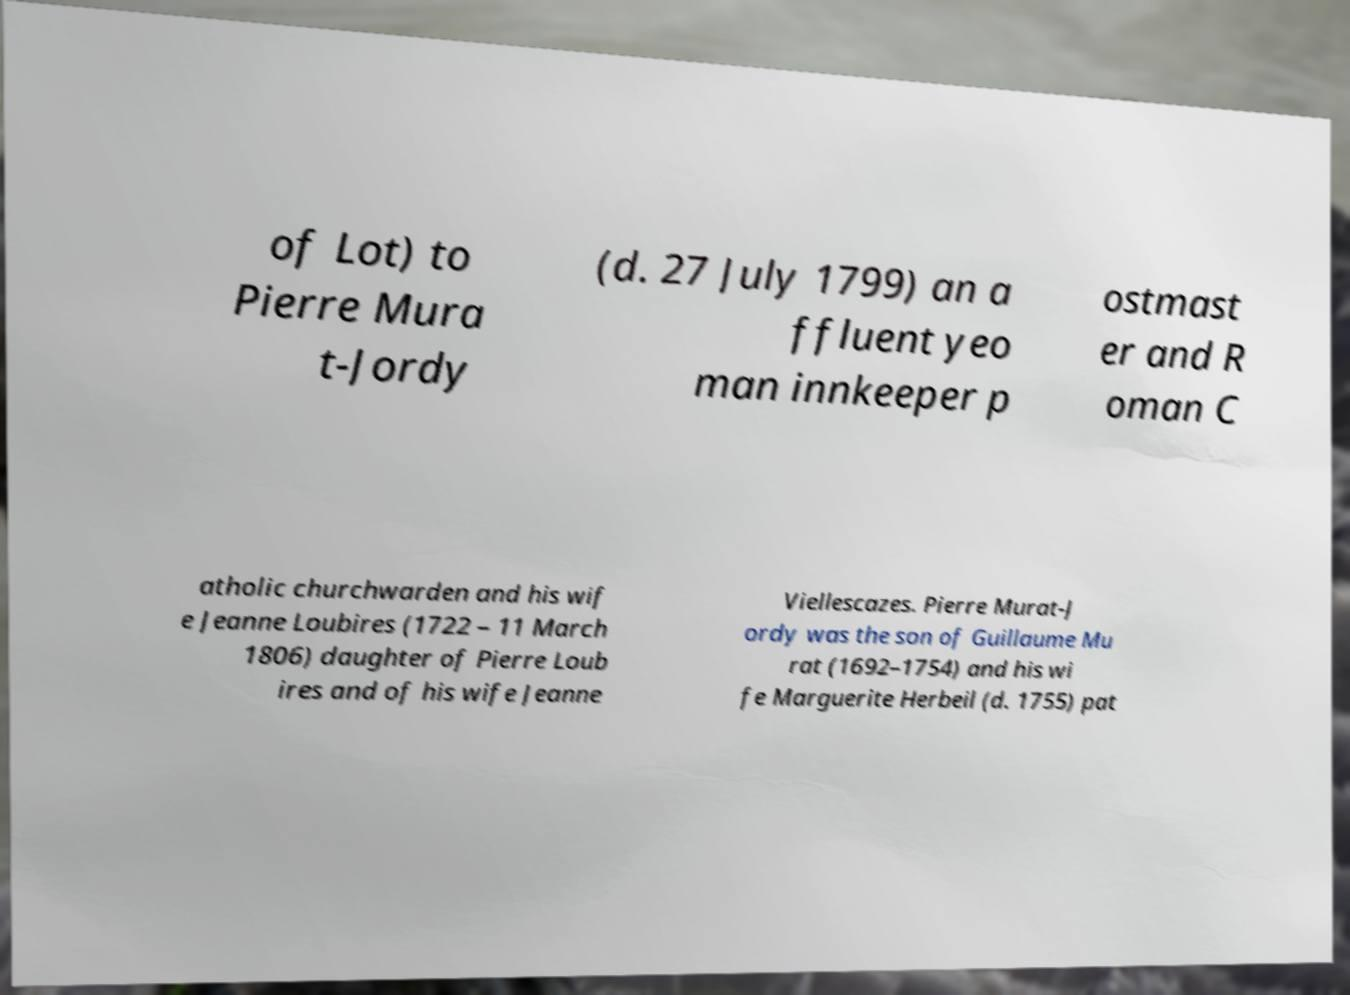Could you assist in decoding the text presented in this image and type it out clearly? of Lot) to Pierre Mura t-Jordy (d. 27 July 1799) an a ffluent yeo man innkeeper p ostmast er and R oman C atholic churchwarden and his wif e Jeanne Loubires (1722 – 11 March 1806) daughter of Pierre Loub ires and of his wife Jeanne Viellescazes. Pierre Murat-J ordy was the son of Guillaume Mu rat (1692–1754) and his wi fe Marguerite Herbeil (d. 1755) pat 